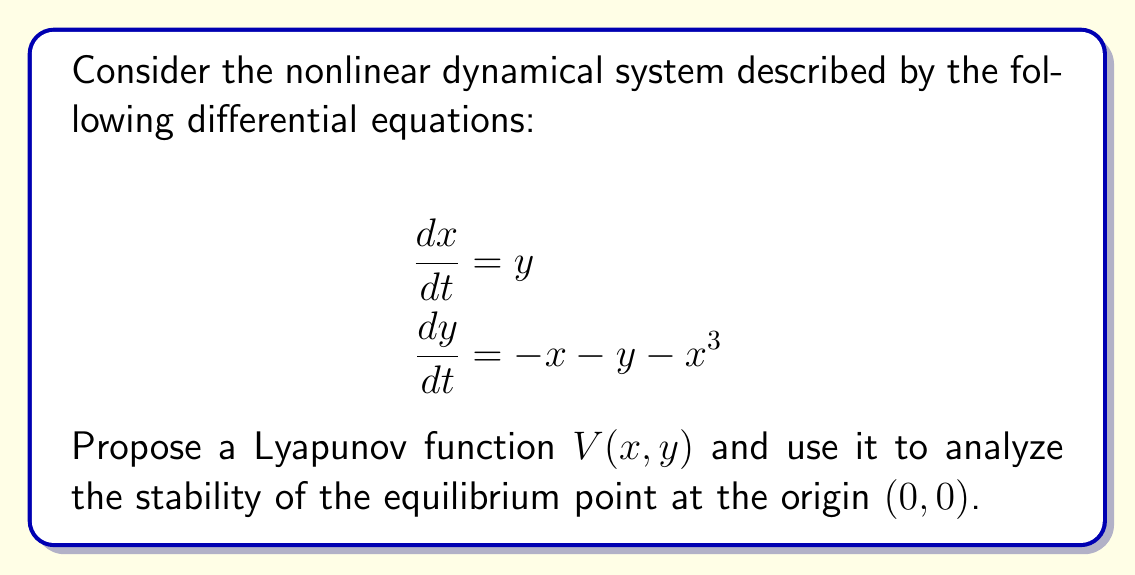Teach me how to tackle this problem. To analyze the stability of the nonlinear dynamical system using Lyapunov functions, we'll follow these steps:

1) First, let's propose a Lyapunov function candidate. A suitable choice for this system is:

   $$V(x,y) = \frac{1}{2}(x^2 + y^2) + \frac{1}{4}x^4$$

2) We need to verify that $V(x,y)$ is positive definite. This is true because:
   - $V(0,0) = 0$
   - For any $(x,y) \neq (0,0)$, $V(x,y) > 0$

3) Next, we calculate the time derivative of $V$ along the trajectories of the system:

   $$\begin{align}
   \frac{dV}{dt} &= \frac{\partial V}{\partial x}\frac{dx}{dt} + \frac{\partial V}{\partial y}\frac{dy}{dt} \\
   &= (x + x^3)y + y(-x - y - x^3) \\
   &= xy + x^3y - xy - y^2 - x^3y \\
   &= -y^2
   \end{align}$$

4) We observe that $\frac{dV}{dt}$ is negative semidefinite:
   - $\frac{dV}{dt} \leq 0$ for all $(x,y)$
   - $\frac{dV}{dt} = 0$ when $y = 0$ (not only at the origin)

5) Since $\frac{dV}{dt}$ is only negative semidefinite (not strictly negative definite), we can't conclude asymptotic stability directly. We need to use LaSalle's Invariance Principle.

6) Consider the set $E = \{(x,y) : \frac{dV}{dt} = 0\} = \{(x,0) : x \in \mathbb{R}\}$

7) In this set, the system dynamics become:
   $$\begin{align}
   \frac{dx}{dt} &= 0 \\
   \frac{dy}{dt} &= -x - x^3
   \end{align}$$

8) The only solution that can stay identically in $E$ is the origin $(0,0)$, as any other point will lead to $y$ changing.

9) Therefore, by LaSalle's Invariance Principle, all solutions converge to the origin as $t \rightarrow \infty$.
Answer: The equilibrium point $(0,0)$ is asymptotically stable. 